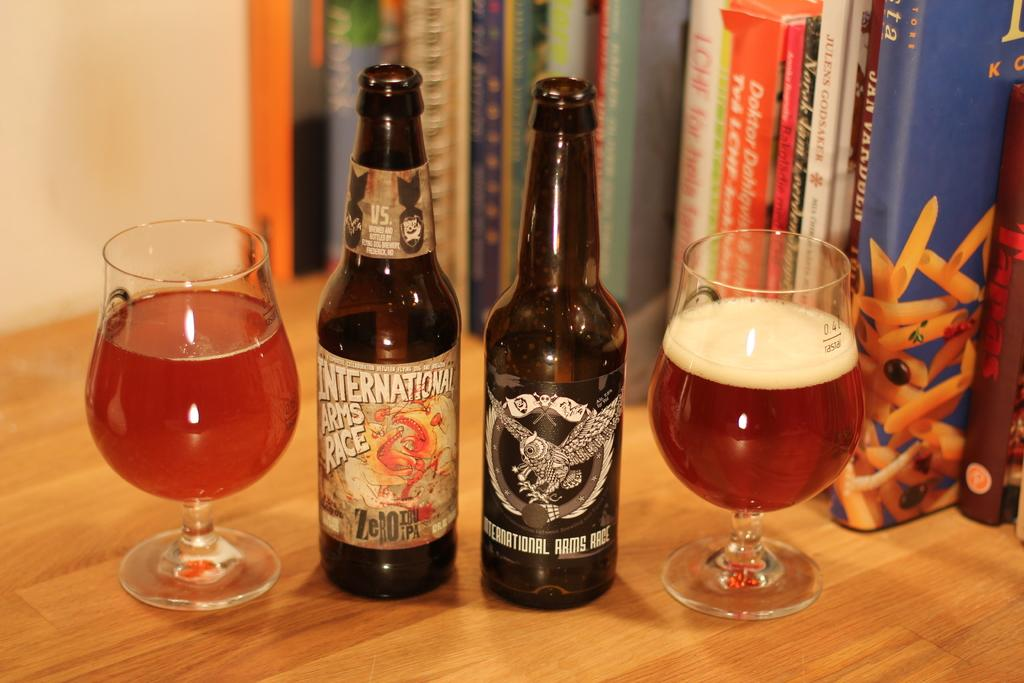Provide a one-sentence caption for the provided image. the word international is on the front of a beer bottle. 